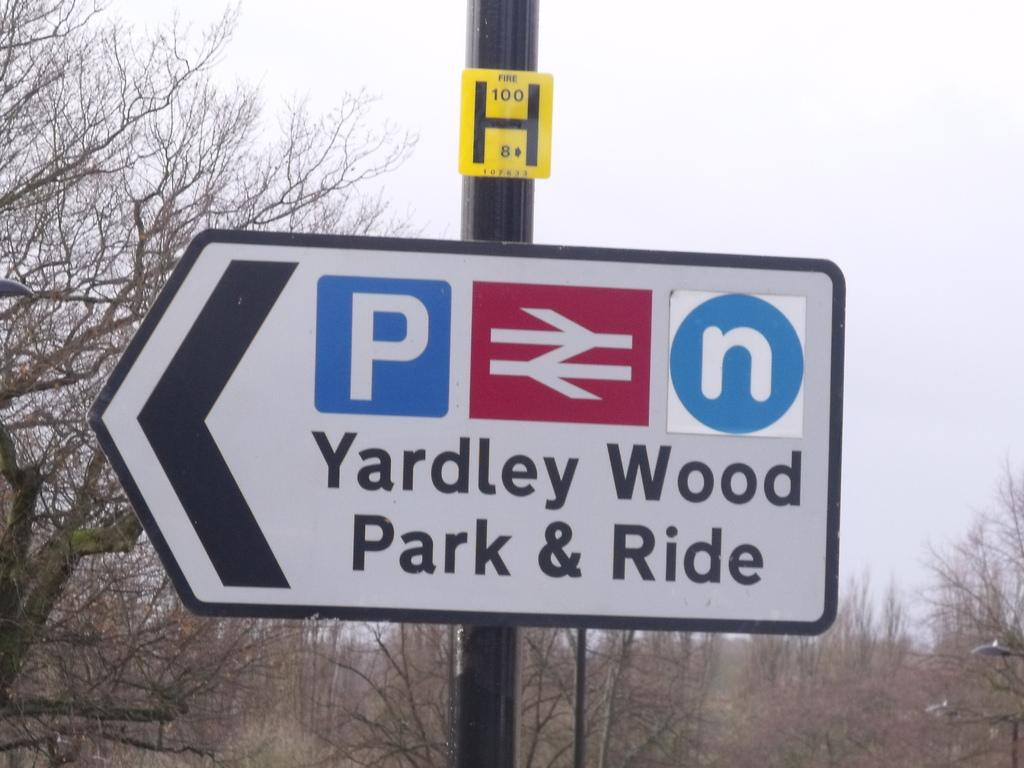<image>
Relay a brief, clear account of the picture shown. a sign outside that has the word Yardley wood park on it 